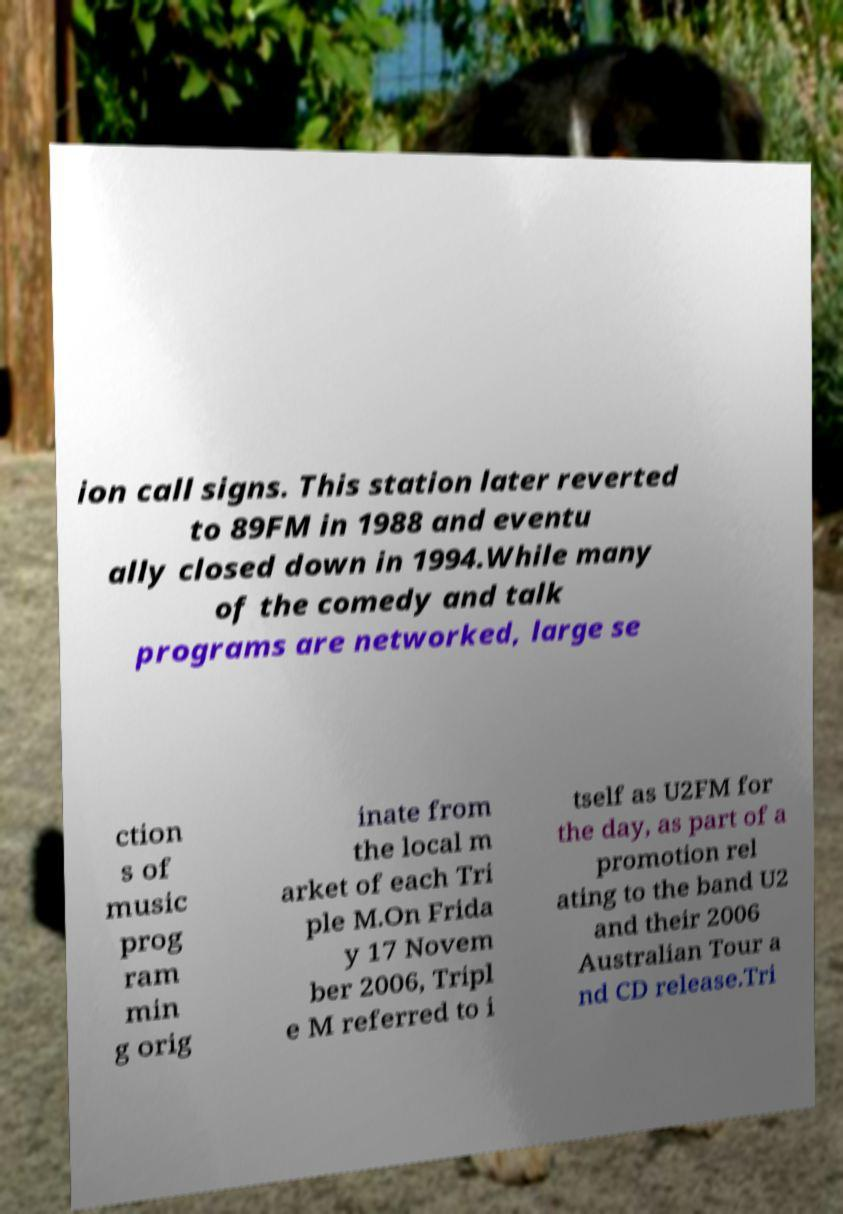Could you assist in decoding the text presented in this image and type it out clearly? ion call signs. This station later reverted to 89FM in 1988 and eventu ally closed down in 1994.While many of the comedy and talk programs are networked, large se ction s of music prog ram min g orig inate from the local m arket of each Tri ple M.On Frida y 17 Novem ber 2006, Tripl e M referred to i tself as U2FM for the day, as part of a promotion rel ating to the band U2 and their 2006 Australian Tour a nd CD release.Tri 